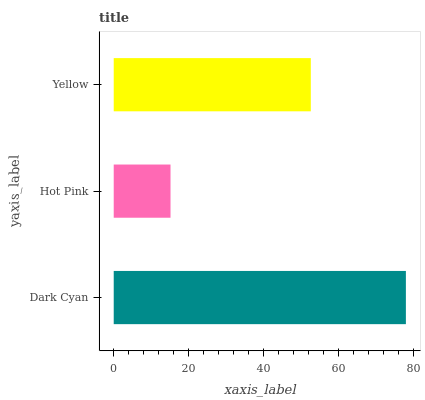Is Hot Pink the minimum?
Answer yes or no. Yes. Is Dark Cyan the maximum?
Answer yes or no. Yes. Is Yellow the minimum?
Answer yes or no. No. Is Yellow the maximum?
Answer yes or no. No. Is Yellow greater than Hot Pink?
Answer yes or no. Yes. Is Hot Pink less than Yellow?
Answer yes or no. Yes. Is Hot Pink greater than Yellow?
Answer yes or no. No. Is Yellow less than Hot Pink?
Answer yes or no. No. Is Yellow the high median?
Answer yes or no. Yes. Is Yellow the low median?
Answer yes or no. Yes. Is Hot Pink the high median?
Answer yes or no. No. Is Hot Pink the low median?
Answer yes or no. No. 